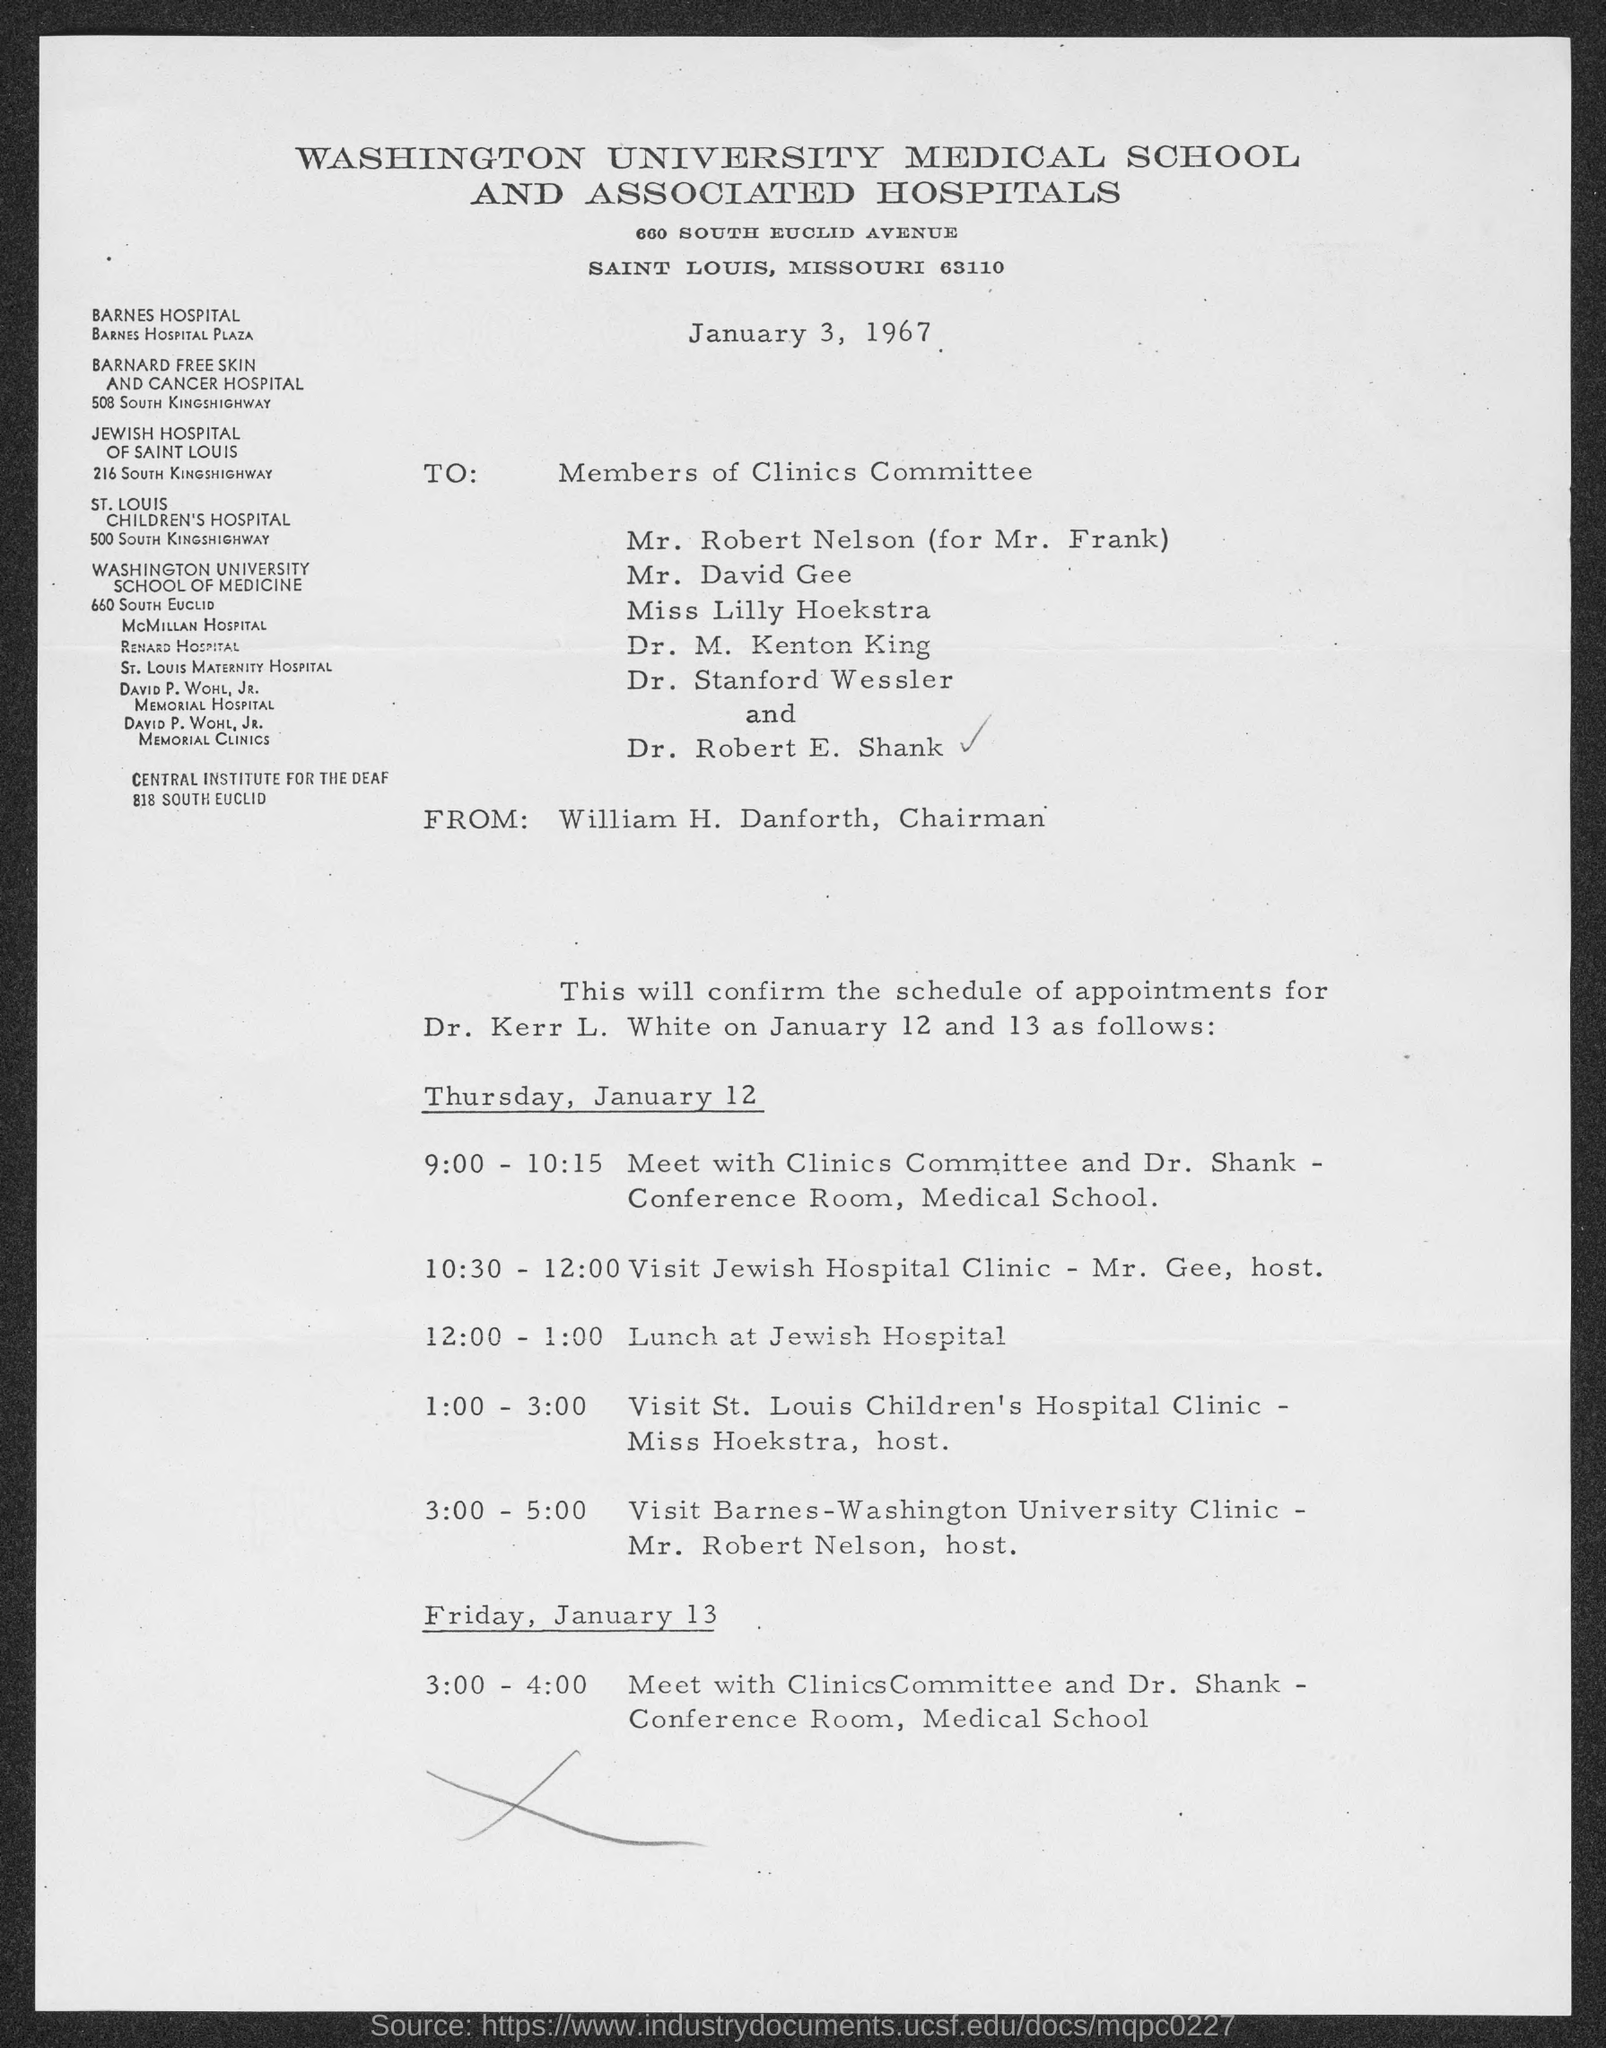Indicate a few pertinent items in this graphic. I have an appointment from 12:00 - 1:00 that is lunch at Jewish Hospital. The schedule of appointments is for Dr. Kerr L. White. The document is dated January 3, 1967. The document is from William H. Danforth, the chairman. 